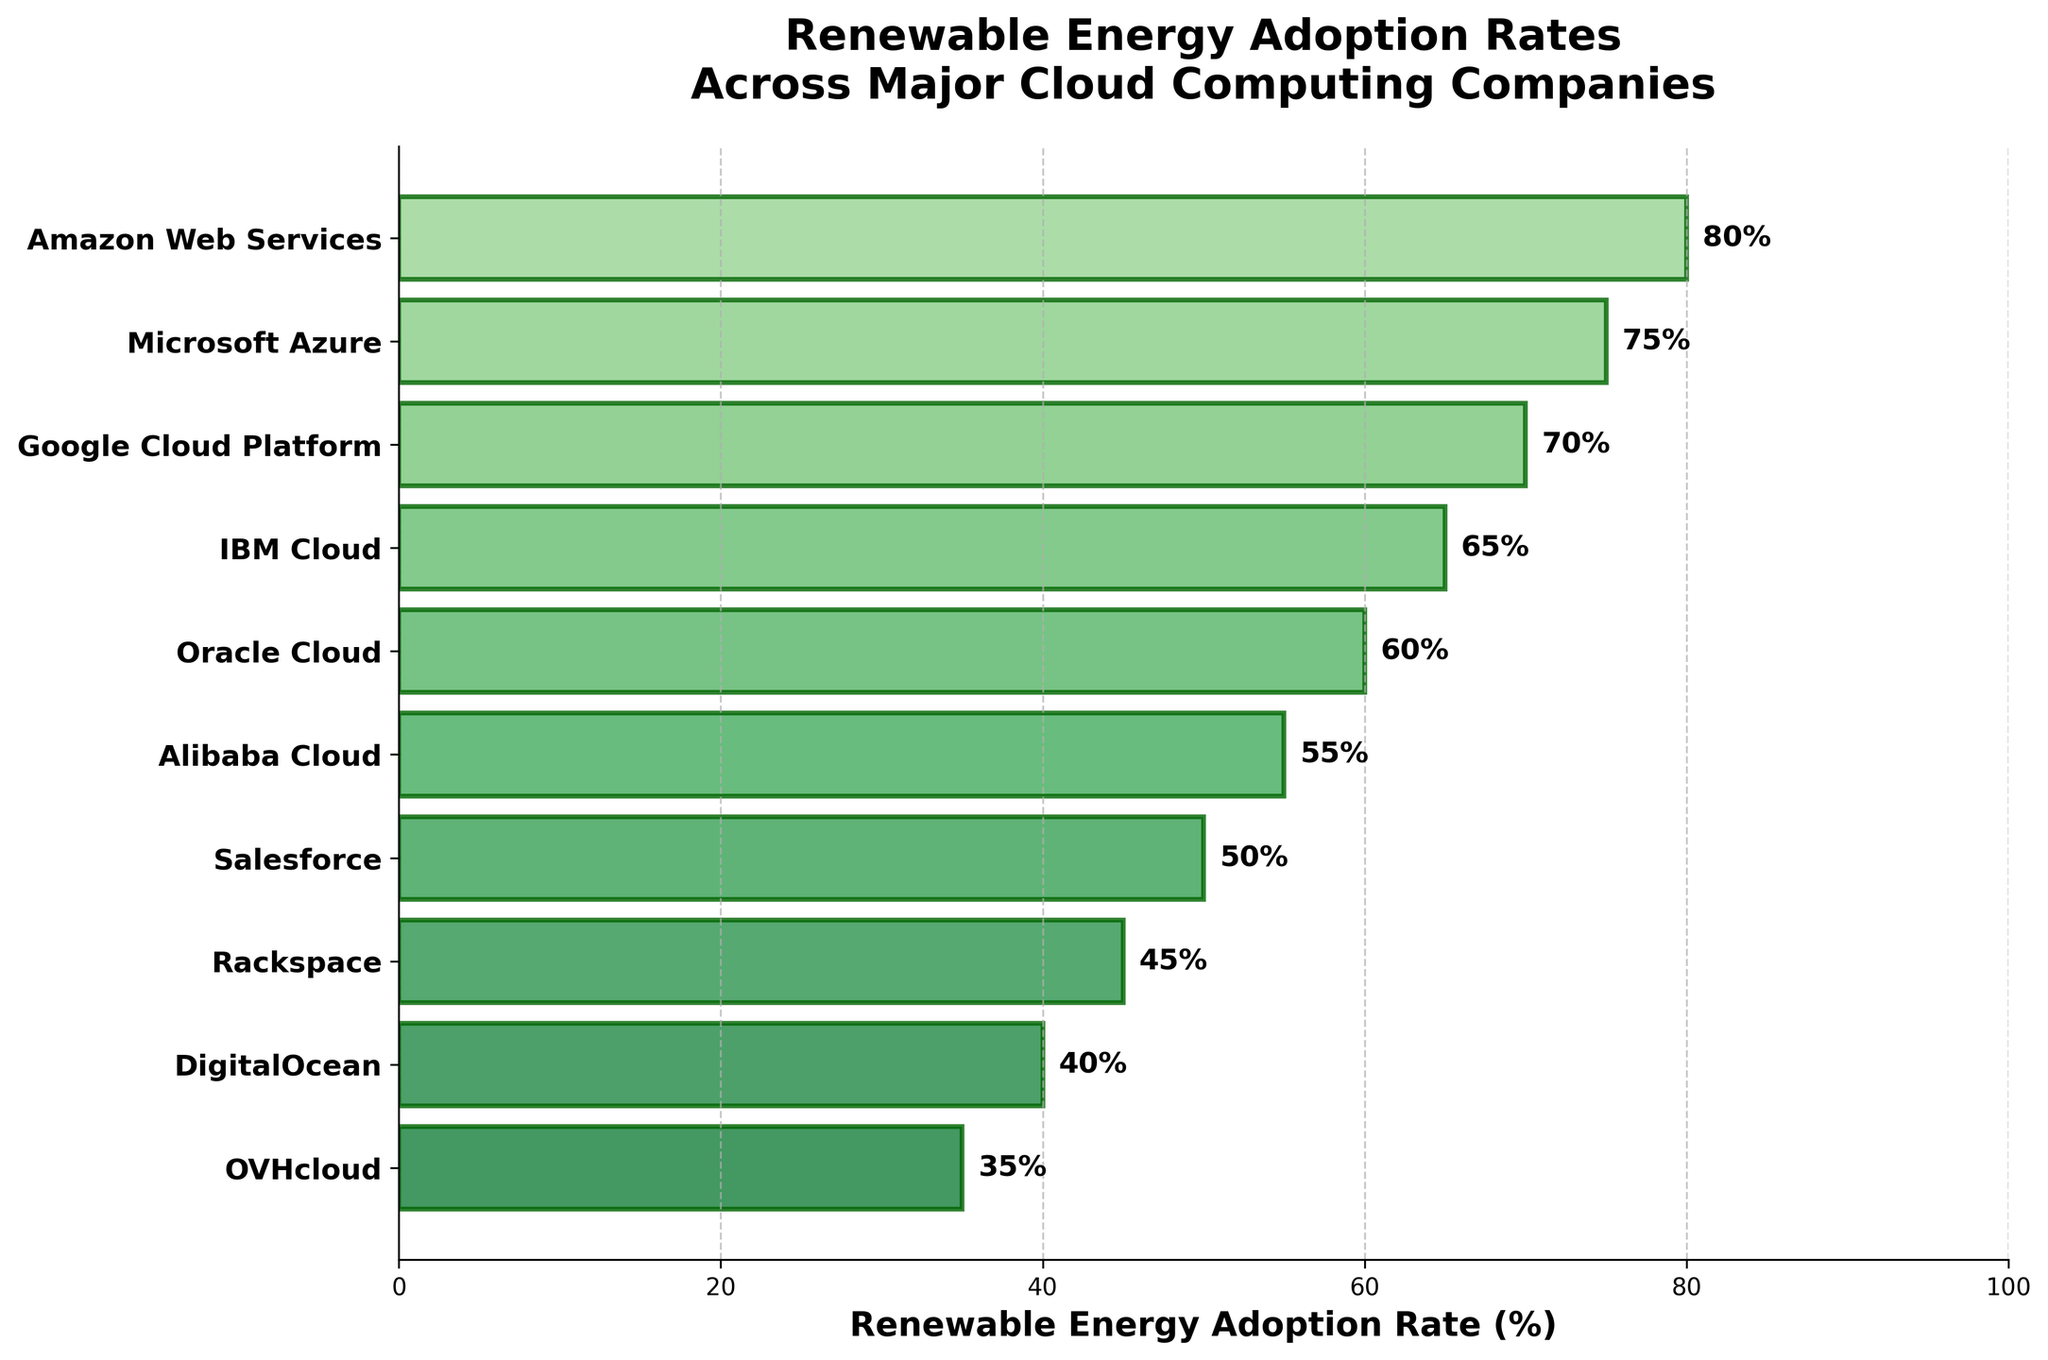Who has the highest renewable energy adoption rate among the companies? The company with the highest bar length on the horizontal axis has the highest adoption rate. According to the chart, Amazon Web Services has the longest bar at 80%.
Answer: Amazon Web Services What is the title of the figure? The title is written on top of the figure, typically in a larger and bold font. It reads "Renewable Energy Adoption Rates Across Major Cloud Computing Companies."
Answer: Renewable Energy Adoption Rates Across Major Cloud Computing Companies How many companies have a renewable energy adoption rate of 60% or higher? Check the bars extending to the right of the 60% mark or higher. Amazon Web Services, Microsoft Azure, Google Cloud Platform, IBM Cloud, and Oracle Cloud meet this criterion, totaling five companies.
Answer: Five Which company has the lowest renewable energy adoption rate? The company with the shortest bar on the horizontal axis. OVHcloud has the shortest bar indicating a 35% adoption rate.
Answer: OVHcloud What is the difference in renewable energy adoption rates between Salesforce and Oracle Cloud? Identify the bars corresponding to Salesforce and Oracle Cloud. The rates are 50% and 60%, respectively. The difference is calculated as 60% - 50%.
Answer: 10% By how much does Google Cloud Platform's adoption rate exceed that of Rackspace? Google Cloud Platform has a rate of 70%, and Rackspace has 45%. Calculate the difference: 70% - 45%.
Answer: 25% What is the average renewable energy adoption rate of the bottom three companies? The bottom three companies are DigitalOcean (40%), Rackspace (45%), and OVHcloud (35%). Calculate the average by summing their rates (40 + 45 + 35) and dividing by 3.
Answer: 40% How does the renewable energy adoption rate of IBM Cloud compare to Microsoft Azure? Identify the bars for IBM Cloud and Microsoft Azure. IBM has a 65% adoption rate while Microsoft has 75%. Compare: 65% < 75%.
Answer: IBM Cloud is lower What color scheme is used in the funnel chart? The bars are shaded in different greens, indicating a gradient of green shades from light to dark as the values increase.
Answer: Different shades of green Which companies fall in the 50% to 70% renewable energy adoption rate range? Observe the bars within the 50% to 70% range. Salesforce (50%), Oracle Cloud (60%), IBM Cloud (65%), and Google Cloud Platform (70%) fall into this range.
Answer: Salesforce, Oracle Cloud, IBM Cloud, Google Cloud Platform 